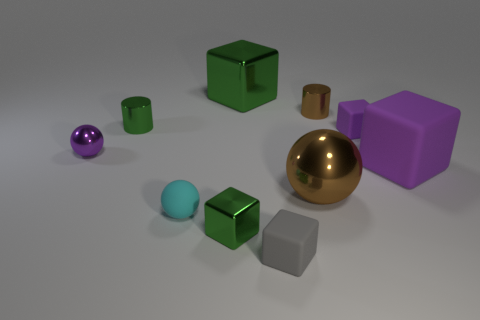Tell me about the colors in this image. The image features a range of colors: there's a purple cube, a couple of green cubes, a blue and a purple sphere, along with the metallic brown sphere and gold cylinder, and two gray objects, one cube and one cylinder.  Do these colors represent anything specific, or are they just random? Without additional context, it seems these colors are chosen randomly or for aesthetic purposes to create a visually engaging composition with a variety of shapes and hues. 